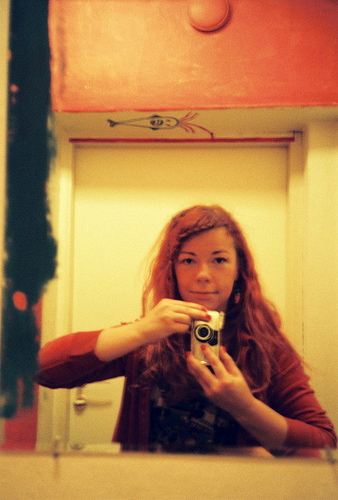<image>
Is there a camera on the door knob? No. The camera is not positioned on the door knob. They may be near each other, but the camera is not supported by or resting on top of the door knob. 